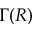Convert formula to latex. <formula><loc_0><loc_0><loc_500><loc_500>\Gamma ( R )</formula> 